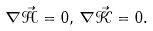<formula> <loc_0><loc_0><loc_500><loc_500>\nabla \vec { \mathcal { H } } = 0 , \, \nabla \vec { \mathcal { K } } = 0 .</formula> 